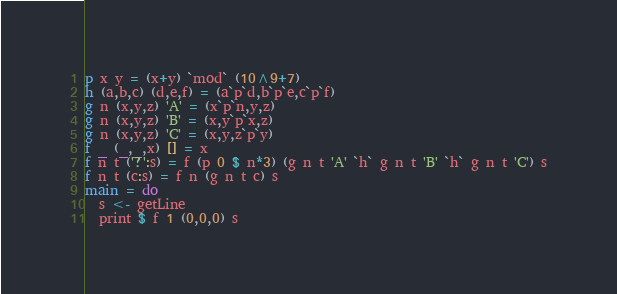Convert code to text. <code><loc_0><loc_0><loc_500><loc_500><_Haskell_>p x y = (x+y) `mod` (10^9+7)
h (a,b,c) (d,e,f) = (a`p`d,b`p`e,c`p`f)
g n (x,y,z) 'A' = (x`p`n,y,z)
g n (x,y,z) 'B' = (x,y`p`x,z)
g n (x,y,z) 'C' = (x,y,z`p`y)
f _ (_,_,x) [] = x 
f n t ('?':s) = f (p 0 $ n*3) (g n t 'A' `h` g n t 'B' `h` g n t 'C') s
f n t (c:s) = f n (g n t c) s
main = do
  s <- getLine
  print $ f 1 (0,0,0) s</code> 